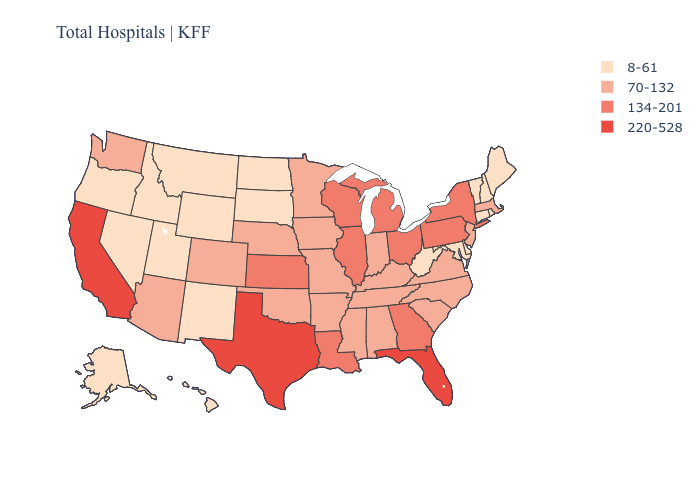Does Rhode Island have the lowest value in the Northeast?
Quick response, please. Yes. Name the states that have a value in the range 220-528?
Quick response, please. California, Florida, Texas. Among the states that border Rhode Island , which have the lowest value?
Concise answer only. Connecticut. Does North Dakota have the highest value in the MidWest?
Quick response, please. No. Does Vermont have a lower value than Pennsylvania?
Give a very brief answer. Yes. Does New Mexico have the same value as North Carolina?
Write a very short answer. No. What is the lowest value in the West?
Keep it brief. 8-61. Does Texas have the lowest value in the South?
Short answer required. No. Name the states that have a value in the range 220-528?
Keep it brief. California, Florida, Texas. What is the value of Alabama?
Keep it brief. 70-132. Does the map have missing data?
Concise answer only. No. Name the states that have a value in the range 134-201?
Keep it brief. Georgia, Illinois, Kansas, Louisiana, Michigan, New York, Ohio, Pennsylvania, Wisconsin. What is the value of Minnesota?
Answer briefly. 70-132. Among the states that border Delaware , does New Jersey have the lowest value?
Concise answer only. No. What is the highest value in the South ?
Answer briefly. 220-528. 